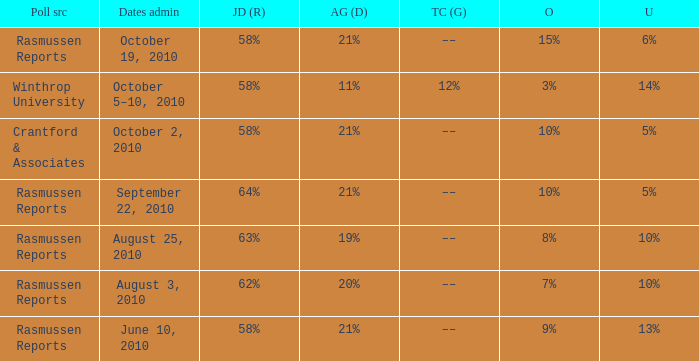What was the vote for Alvin Green when Jim DeMint was 62%? 20%. 